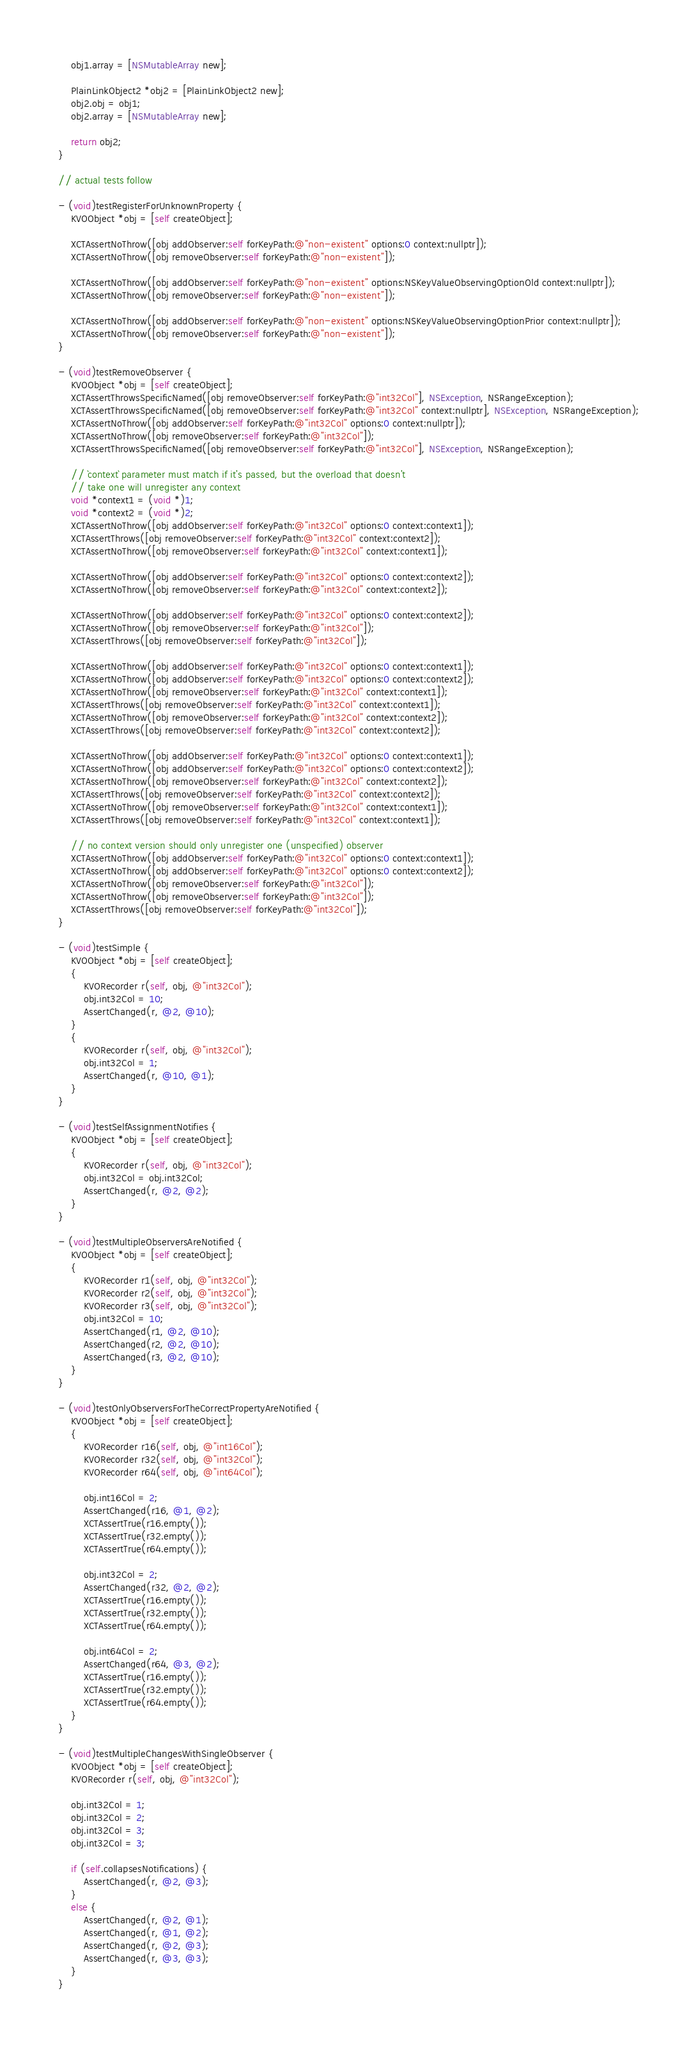<code> <loc_0><loc_0><loc_500><loc_500><_ObjectiveC_>    obj1.array = [NSMutableArray new];

    PlainLinkObject2 *obj2 = [PlainLinkObject2 new];
    obj2.obj = obj1;
    obj2.array = [NSMutableArray new];

    return obj2;
}

// actual tests follow

- (void)testRegisterForUnknownProperty {
    KVOObject *obj = [self createObject];

    XCTAssertNoThrow([obj addObserver:self forKeyPath:@"non-existent" options:0 context:nullptr]);
    XCTAssertNoThrow([obj removeObserver:self forKeyPath:@"non-existent"]);

    XCTAssertNoThrow([obj addObserver:self forKeyPath:@"non-existent" options:NSKeyValueObservingOptionOld context:nullptr]);
    XCTAssertNoThrow([obj removeObserver:self forKeyPath:@"non-existent"]);

    XCTAssertNoThrow([obj addObserver:self forKeyPath:@"non-existent" options:NSKeyValueObservingOptionPrior context:nullptr]);
    XCTAssertNoThrow([obj removeObserver:self forKeyPath:@"non-existent"]);
}

- (void)testRemoveObserver {
    KVOObject *obj = [self createObject];
    XCTAssertThrowsSpecificNamed([obj removeObserver:self forKeyPath:@"int32Col"], NSException, NSRangeException);
    XCTAssertThrowsSpecificNamed([obj removeObserver:self forKeyPath:@"int32Col" context:nullptr], NSException, NSRangeException);
    XCTAssertNoThrow([obj addObserver:self forKeyPath:@"int32Col" options:0 context:nullptr]);
    XCTAssertNoThrow([obj removeObserver:self forKeyPath:@"int32Col"]);
    XCTAssertThrowsSpecificNamed([obj removeObserver:self forKeyPath:@"int32Col"], NSException, NSRangeException);

    // `context` parameter must match if it's passed, but the overload that doesn't
    // take one will unregister any context
    void *context1 = (void *)1;
    void *context2 = (void *)2;
    XCTAssertNoThrow([obj addObserver:self forKeyPath:@"int32Col" options:0 context:context1]);
    XCTAssertThrows([obj removeObserver:self forKeyPath:@"int32Col" context:context2]);
    XCTAssertNoThrow([obj removeObserver:self forKeyPath:@"int32Col" context:context1]);

    XCTAssertNoThrow([obj addObserver:self forKeyPath:@"int32Col" options:0 context:context2]);
    XCTAssertNoThrow([obj removeObserver:self forKeyPath:@"int32Col" context:context2]);

    XCTAssertNoThrow([obj addObserver:self forKeyPath:@"int32Col" options:0 context:context2]);
    XCTAssertNoThrow([obj removeObserver:self forKeyPath:@"int32Col"]);
    XCTAssertThrows([obj removeObserver:self forKeyPath:@"int32Col"]);

    XCTAssertNoThrow([obj addObserver:self forKeyPath:@"int32Col" options:0 context:context1]);
    XCTAssertNoThrow([obj addObserver:self forKeyPath:@"int32Col" options:0 context:context2]);
    XCTAssertNoThrow([obj removeObserver:self forKeyPath:@"int32Col" context:context1]);
    XCTAssertThrows([obj removeObserver:self forKeyPath:@"int32Col" context:context1]);
    XCTAssertNoThrow([obj removeObserver:self forKeyPath:@"int32Col" context:context2]);
    XCTAssertThrows([obj removeObserver:self forKeyPath:@"int32Col" context:context2]);

    XCTAssertNoThrow([obj addObserver:self forKeyPath:@"int32Col" options:0 context:context1]);
    XCTAssertNoThrow([obj addObserver:self forKeyPath:@"int32Col" options:0 context:context2]);
    XCTAssertNoThrow([obj removeObserver:self forKeyPath:@"int32Col" context:context2]);
    XCTAssertThrows([obj removeObserver:self forKeyPath:@"int32Col" context:context2]);
    XCTAssertNoThrow([obj removeObserver:self forKeyPath:@"int32Col" context:context1]);
    XCTAssertThrows([obj removeObserver:self forKeyPath:@"int32Col" context:context1]);

    // no context version should only unregister one (unspecified) observer
    XCTAssertNoThrow([obj addObserver:self forKeyPath:@"int32Col" options:0 context:context1]);
    XCTAssertNoThrow([obj addObserver:self forKeyPath:@"int32Col" options:0 context:context2]);
    XCTAssertNoThrow([obj removeObserver:self forKeyPath:@"int32Col"]);
    XCTAssertNoThrow([obj removeObserver:self forKeyPath:@"int32Col"]);
    XCTAssertThrows([obj removeObserver:self forKeyPath:@"int32Col"]);
}

- (void)testSimple {
    KVOObject *obj = [self createObject];
    {
        KVORecorder r(self, obj, @"int32Col");
        obj.int32Col = 10;
        AssertChanged(r, @2, @10);
    }
    {
        KVORecorder r(self, obj, @"int32Col");
        obj.int32Col = 1;
        AssertChanged(r, @10, @1);
    }
}

- (void)testSelfAssignmentNotifies {
    KVOObject *obj = [self createObject];
    {
        KVORecorder r(self, obj, @"int32Col");
        obj.int32Col = obj.int32Col;
        AssertChanged(r, @2, @2);
    }
}

- (void)testMultipleObserversAreNotified {
    KVOObject *obj = [self createObject];
    {
        KVORecorder r1(self, obj, @"int32Col");
        KVORecorder r2(self, obj, @"int32Col");
        KVORecorder r3(self, obj, @"int32Col");
        obj.int32Col = 10;
        AssertChanged(r1, @2, @10);
        AssertChanged(r2, @2, @10);
        AssertChanged(r3, @2, @10);
    }
}

- (void)testOnlyObserversForTheCorrectPropertyAreNotified {
    KVOObject *obj = [self createObject];
    {
        KVORecorder r16(self, obj, @"int16Col");
        KVORecorder r32(self, obj, @"int32Col");
        KVORecorder r64(self, obj, @"int64Col");

        obj.int16Col = 2;
        AssertChanged(r16, @1, @2);
        XCTAssertTrue(r16.empty());
        XCTAssertTrue(r32.empty());
        XCTAssertTrue(r64.empty());

        obj.int32Col = 2;
        AssertChanged(r32, @2, @2);
        XCTAssertTrue(r16.empty());
        XCTAssertTrue(r32.empty());
        XCTAssertTrue(r64.empty());

        obj.int64Col = 2;
        AssertChanged(r64, @3, @2);
        XCTAssertTrue(r16.empty());
        XCTAssertTrue(r32.empty());
        XCTAssertTrue(r64.empty());
    }
}

- (void)testMultipleChangesWithSingleObserver {
    KVOObject *obj = [self createObject];
    KVORecorder r(self, obj, @"int32Col");

    obj.int32Col = 1;
    obj.int32Col = 2;
    obj.int32Col = 3;
    obj.int32Col = 3;

    if (self.collapsesNotifications) {
        AssertChanged(r, @2, @3);
    }
    else {
        AssertChanged(r, @2, @1);
        AssertChanged(r, @1, @2);
        AssertChanged(r, @2, @3);
        AssertChanged(r, @3, @3);
    }
}
</code> 